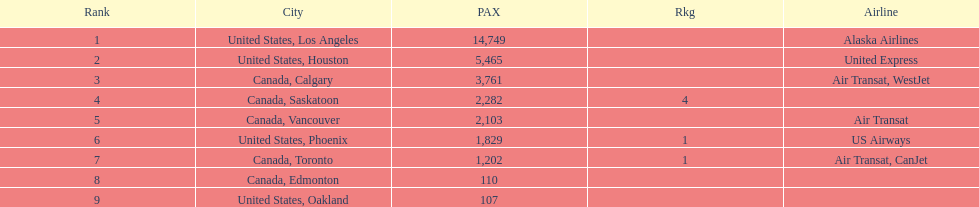The difference in passengers between los angeles and toronto 13,547. 